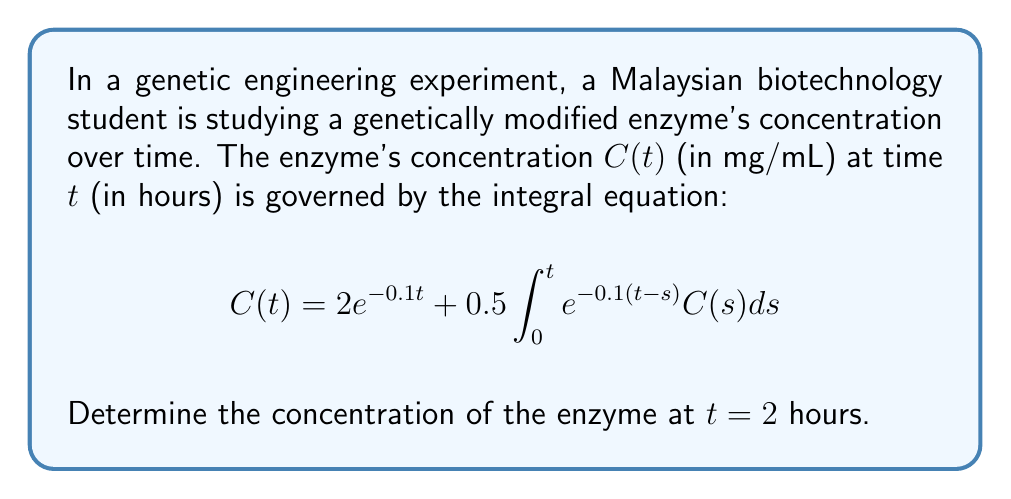Solve this math problem. To solve this integral equation, we'll use the Laplace transform method:

1) Take the Laplace transform of both sides:
   $$\mathcal{L}\{C(t)\} = \mathcal{L}\{2e^{-0.1t}\} + \mathcal{L}\{0.5\int_0^t e^{-0.1(t-s)}C(s)ds\}$$

2) Let $\mathcal{L}\{C(t)\} = \bar{C}(s)$. Using Laplace transform properties:
   $$\bar{C}(s) = \frac{2}{s+0.1} + 0.5 \cdot \frac{1}{s+0.1} \cdot \bar{C}(s)$$

3) Solve for $\bar{C}(s)$:
   $$\bar{C}(s) = \frac{2}{s+0.1} + \frac{0.5\bar{C}(s)}{s+0.1}$$
   $$\bar{C}(s)(1 - \frac{0.5}{s+0.1}) = \frac{2}{s+0.1}$$
   $$\bar{C}(s) = \frac{2}{s+0.1} \cdot \frac{s+0.1}{s-0.4}$$
   $$\bar{C}(s) = \frac{2}{s-0.4}$$

4) Take the inverse Laplace transform:
   $$C(t) = 2e^{0.4t}$$

5) Evaluate at $t = 2$:
   $$C(2) = 2e^{0.4(2)} = 2e^{0.8} \approx 4.4563 \text{ mg/mL}$$
Answer: $4.4563 \text{ mg/mL}$ 